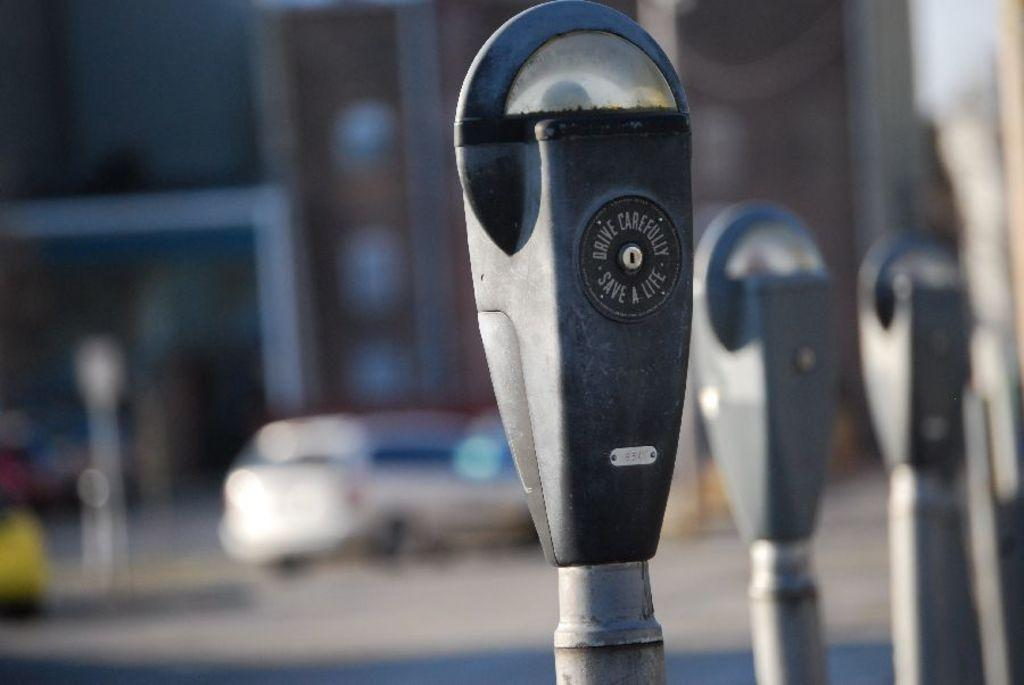<image>
Write a terse but informative summary of the picture. A parking meter shows a friendly warning about driving and saving lives. 